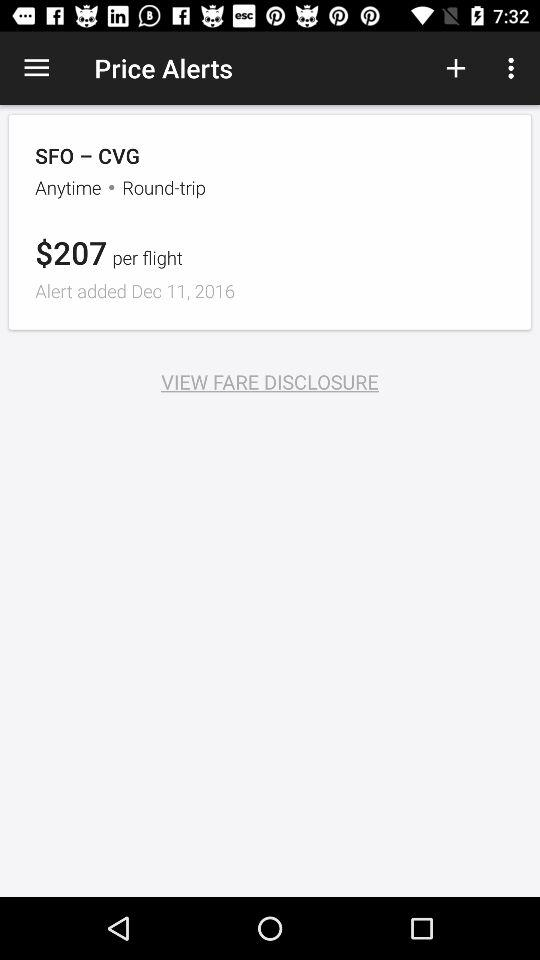What is the cost per flight? The cost per flight is $207. 